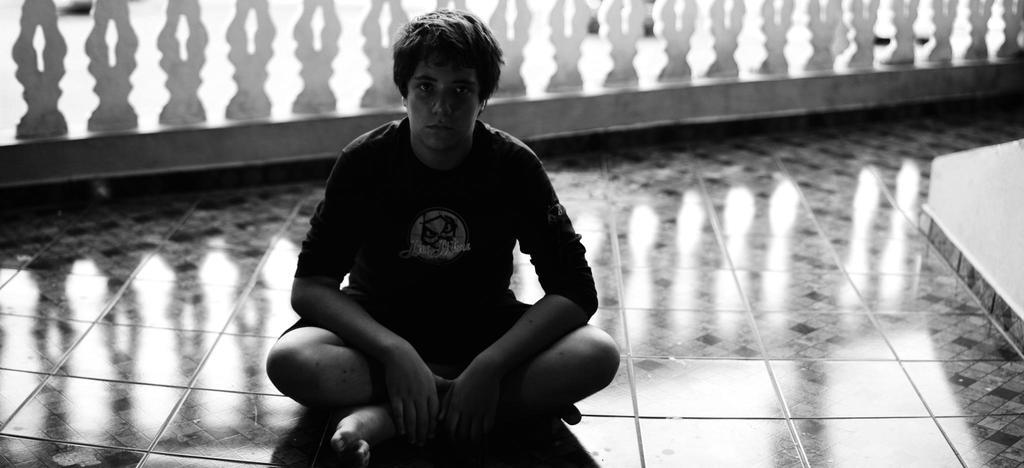What is the person in the image doing? There is a person sitting on the floor in the image. What can be seen in the background of the image? There is a fencing visible in the background of the image. What is the color scheme of the image? The image is in black and white. What disease is the person in the image suffering from? There is no indication of any disease in the image; it only shows a person sitting on the floor. 